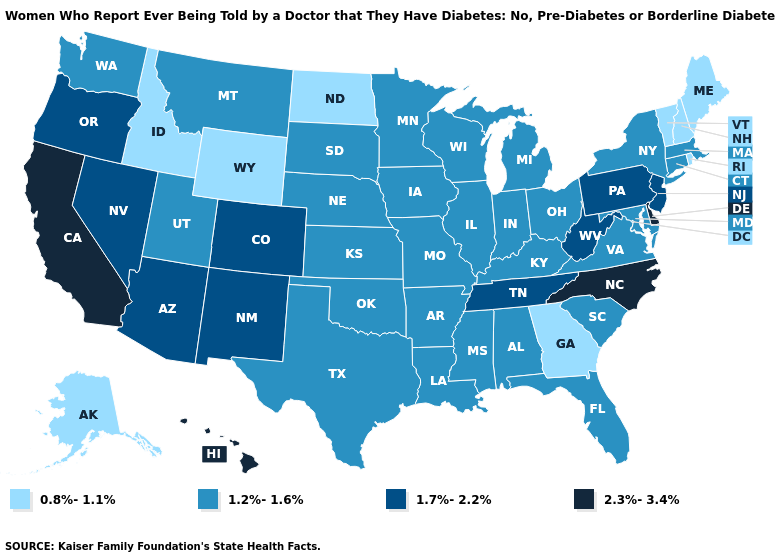What is the highest value in the USA?
Write a very short answer. 2.3%-3.4%. What is the highest value in the USA?
Answer briefly. 2.3%-3.4%. Name the states that have a value in the range 0.8%-1.1%?
Be succinct. Alaska, Georgia, Idaho, Maine, New Hampshire, North Dakota, Rhode Island, Vermont, Wyoming. Which states hav the highest value in the Northeast?
Give a very brief answer. New Jersey, Pennsylvania. What is the value of Utah?
Keep it brief. 1.2%-1.6%. Name the states that have a value in the range 2.3%-3.4%?
Keep it brief. California, Delaware, Hawaii, North Carolina. What is the value of Wyoming?
Give a very brief answer. 0.8%-1.1%. What is the lowest value in the USA?
Short answer required. 0.8%-1.1%. Name the states that have a value in the range 0.8%-1.1%?
Answer briefly. Alaska, Georgia, Idaho, Maine, New Hampshire, North Dakota, Rhode Island, Vermont, Wyoming. Among the states that border Nebraska , which have the lowest value?
Write a very short answer. Wyoming. Does New Jersey have the highest value in the Northeast?
Give a very brief answer. Yes. What is the lowest value in the Northeast?
Be succinct. 0.8%-1.1%. What is the value of Michigan?
Concise answer only. 1.2%-1.6%. What is the value of Pennsylvania?
Keep it brief. 1.7%-2.2%. What is the value of California?
Quick response, please. 2.3%-3.4%. 